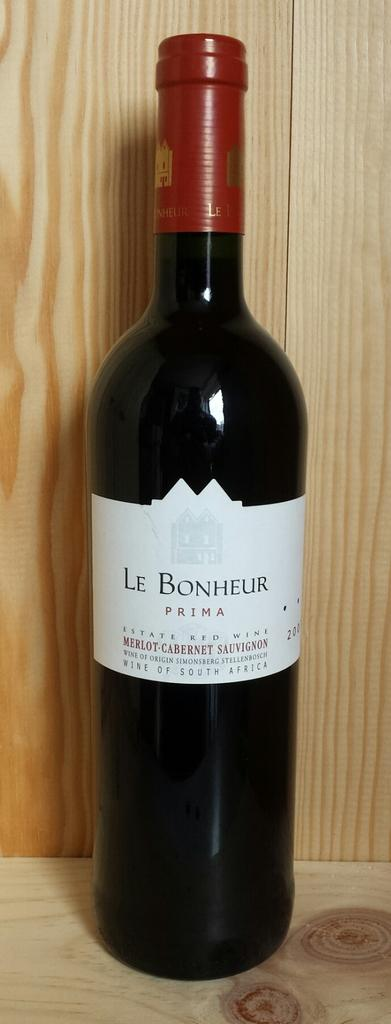<image>
Create a compact narrative representing the image presented. A bottle of wine labelled Le Bonheur Prima. 